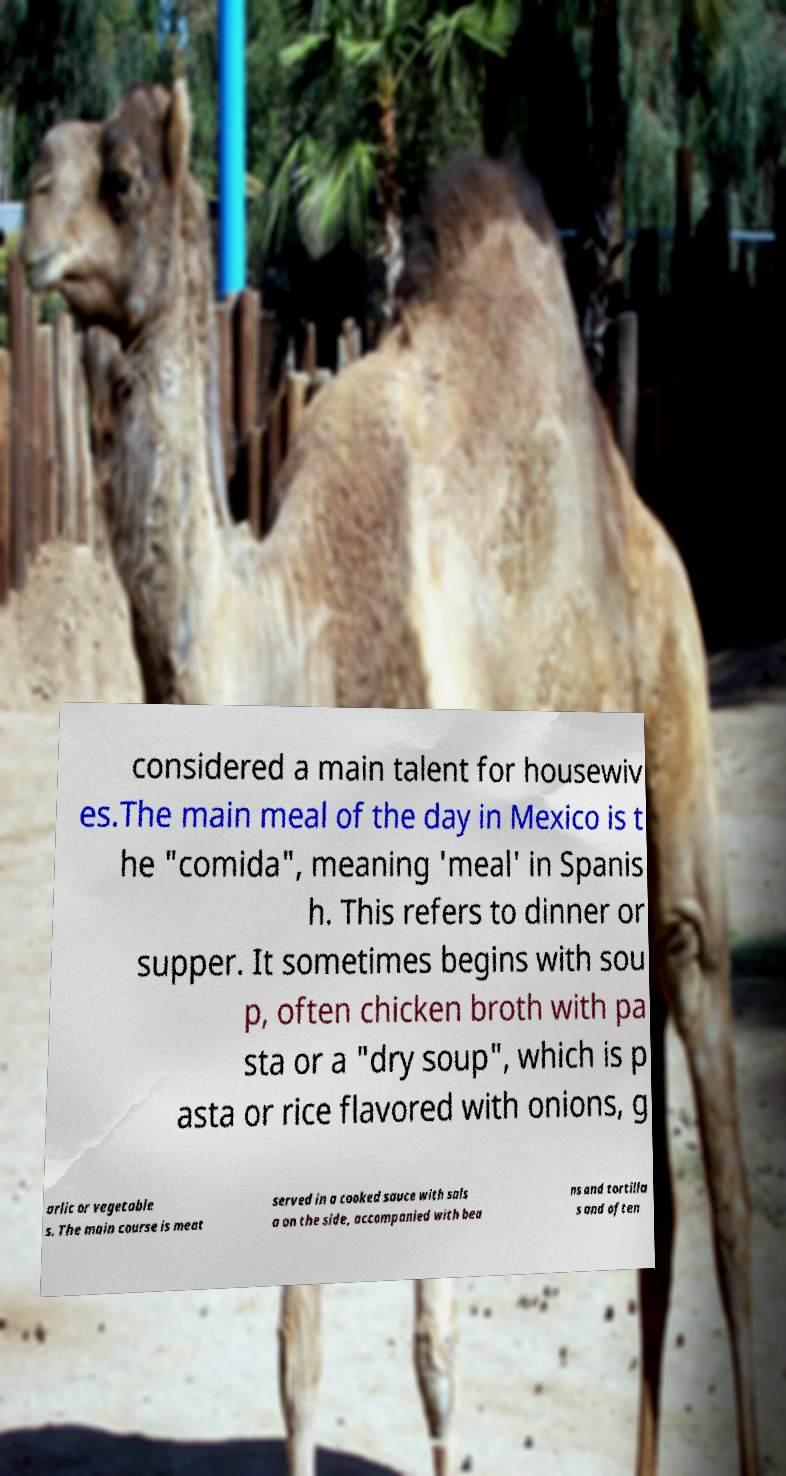There's text embedded in this image that I need extracted. Can you transcribe it verbatim? considered a main talent for housewiv es.The main meal of the day in Mexico is t he "comida", meaning 'meal' in Spanis h. This refers to dinner or supper. It sometimes begins with sou p, often chicken broth with pa sta or a "dry soup", which is p asta or rice flavored with onions, g arlic or vegetable s. The main course is meat served in a cooked sauce with sals a on the side, accompanied with bea ns and tortilla s and often 